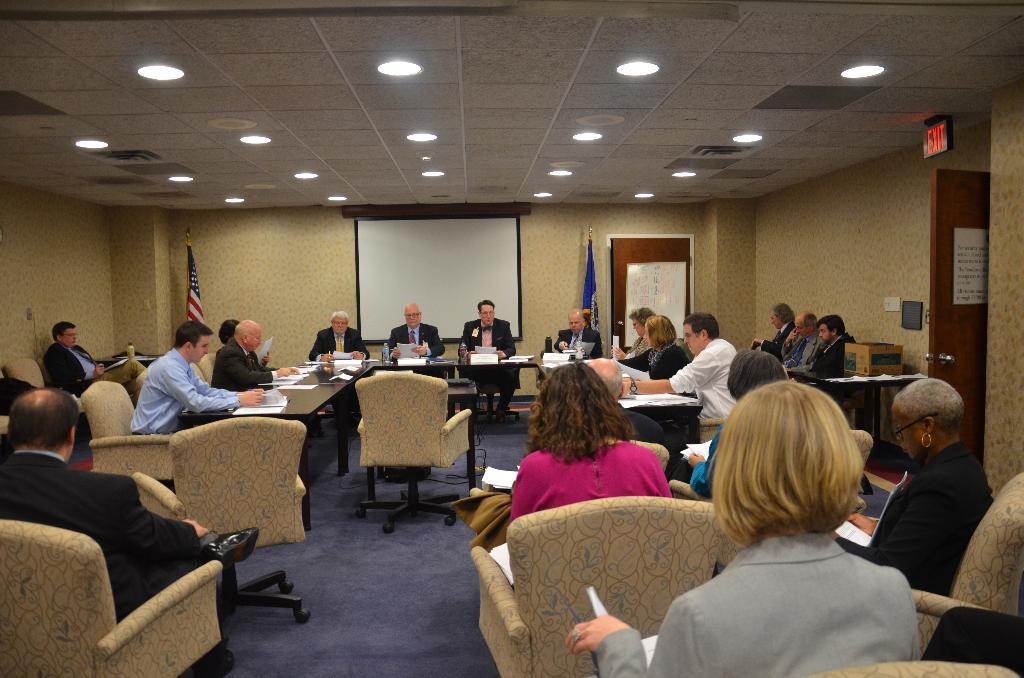How many people are present in the image? There are people in the image, but the exact number is not specified. What type of furniture can be seen in the image? There are tables and chairs in the image. What is the purpose of the whiteboard in the image? The whiteboard in the image is likely used for writing or displaying information. What is the function of the door in the image? The door in the image provides access to another room or area. What type of lighting is present in the image? There are lights in the image, which provide illumination. What are the flags in the image used for? The flags in the image may represent a specific organization, country, or event. Can you tell me how many deer are visible in the image? There are no deer present in the image. What type of cushion is placed on the chairs in the image? There is no mention of cushions on the chairs in the image. 